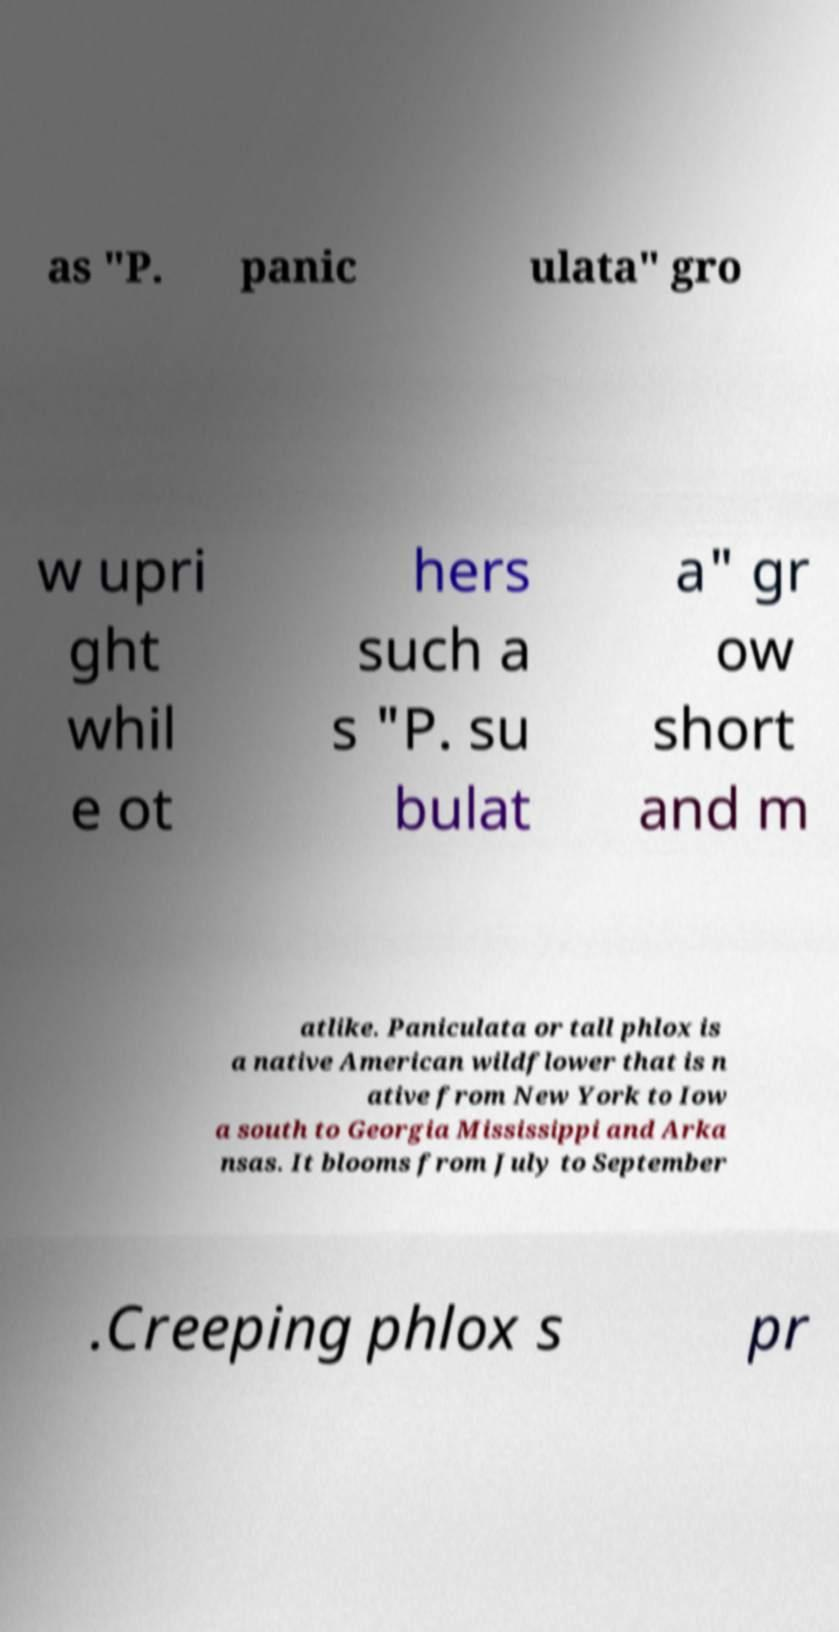Please identify and transcribe the text found in this image. as "P. panic ulata" gro w upri ght whil e ot hers such a s "P. su bulat a" gr ow short and m atlike. Paniculata or tall phlox is a native American wildflower that is n ative from New York to Iow a south to Georgia Mississippi and Arka nsas. It blooms from July to September .Creeping phlox s pr 